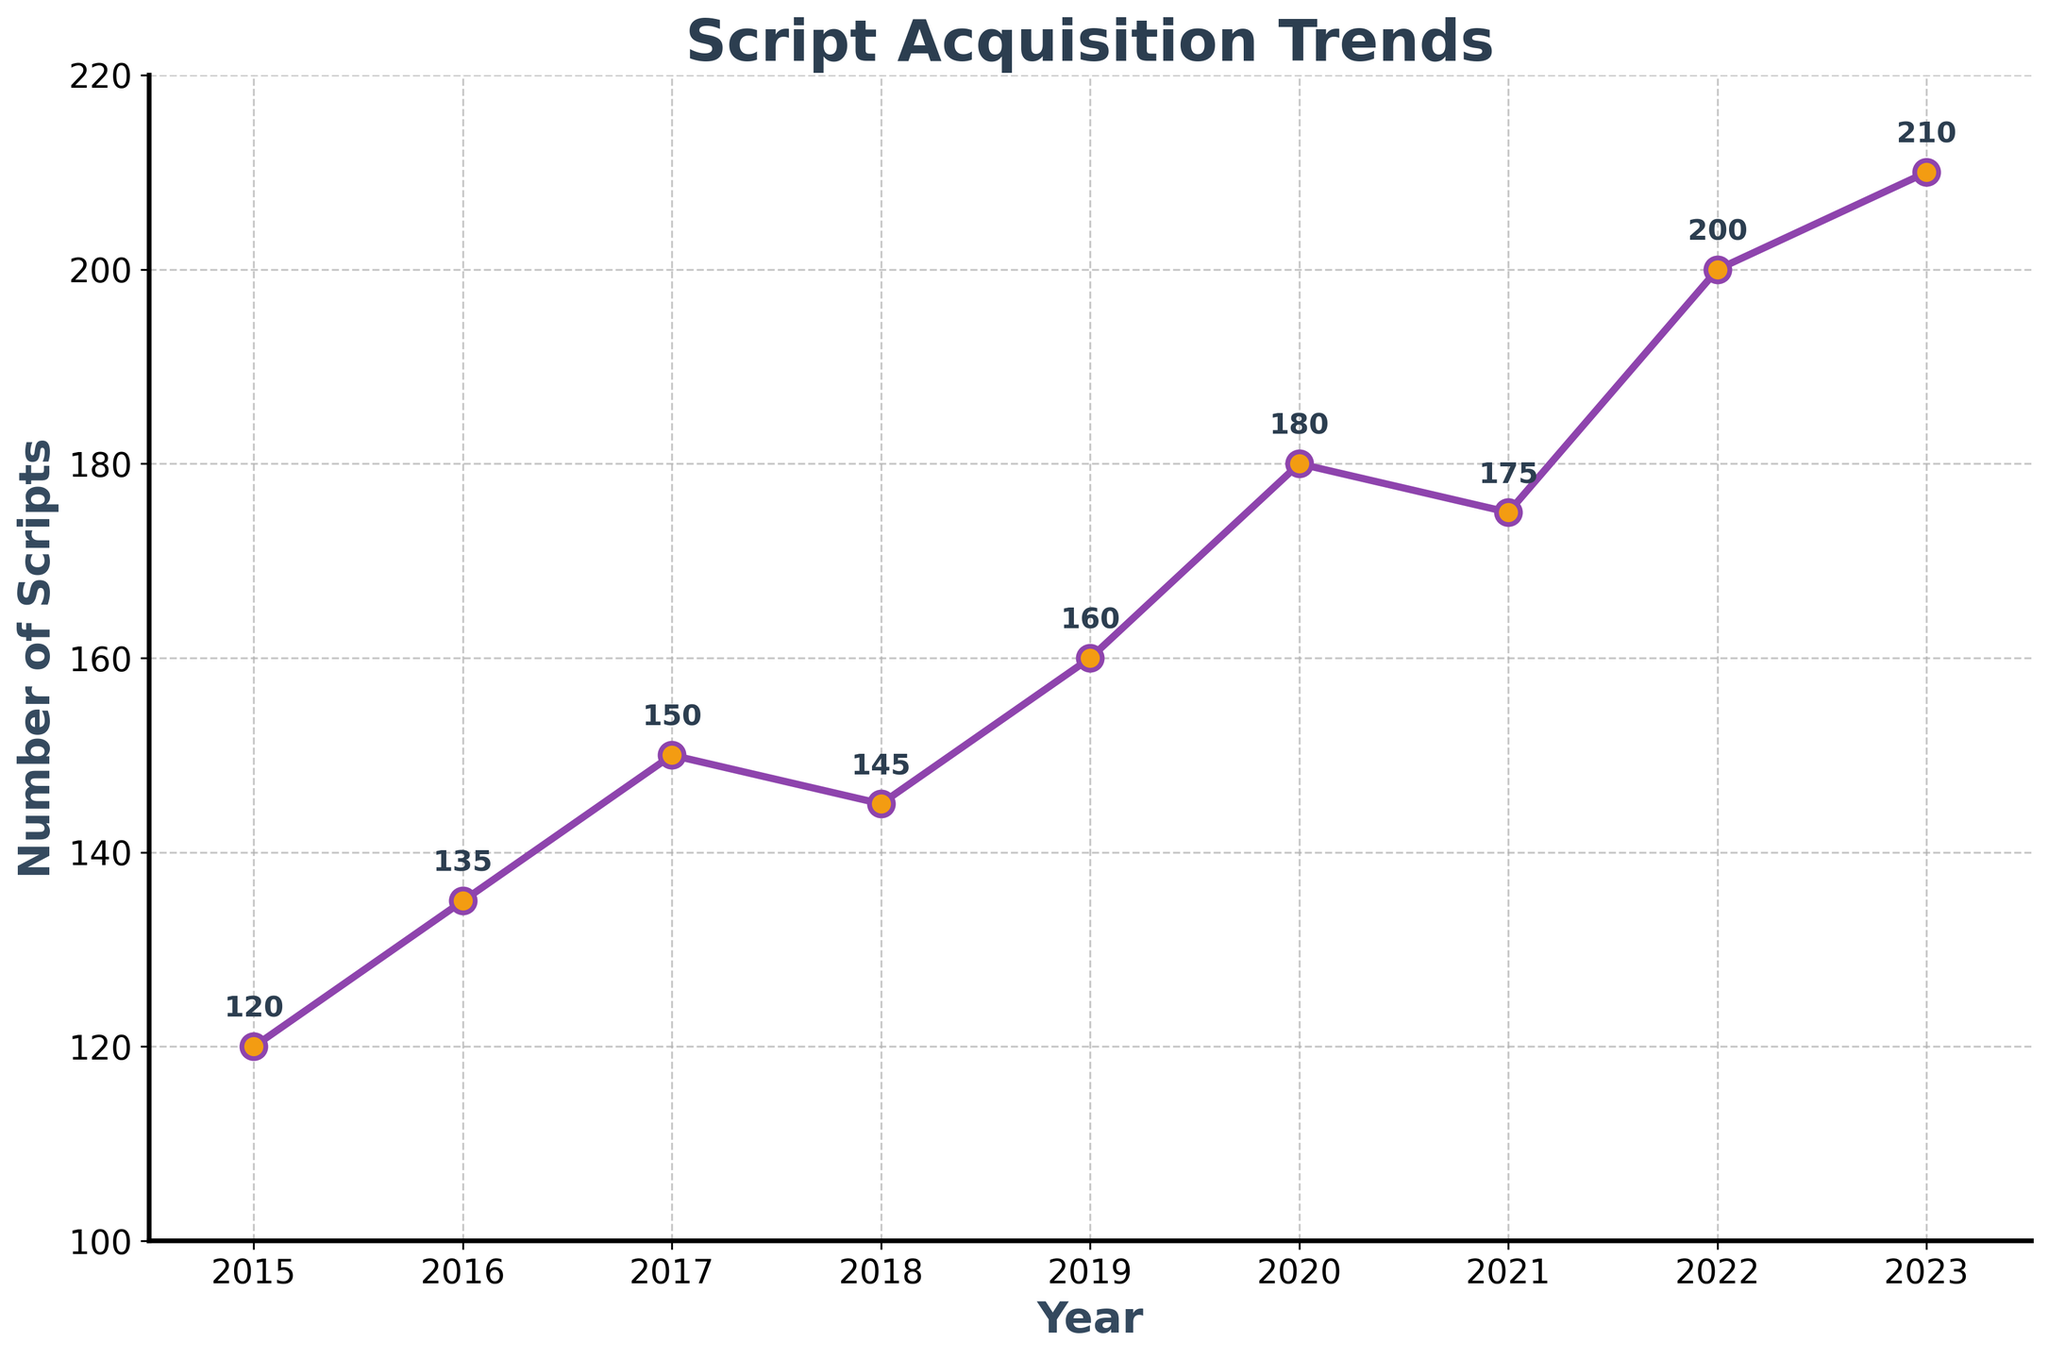What's the title of the plot? The title of the plot is written at the top of the figure, usually in a larger and bolder font.
Answer: Script Acquisition Trends How many years of data are shown in the plot? Count the number of data points plotted on the x-axis, each marked with a specific year.
Answer: 9 years What is the highest number of scripts submitted in a year? Look for the highest data point on the y-axis and see the associated value.
Answer: 210 How did the number of script submissions change from 2018 to 2019? Locate the data points for the years 2018 and 2019. Subtract the 2018 value from the 2019 value to determine the change. 160 - 145 = 15
Answer: Increased by 15 Which year had the lowest number of script submissions? Identify the data point with the smallest value on the y-axis and note its corresponding year on the x-axis.
Answer: 2015 What is the average number of scripts submitted over the years shown? Add up all the script submission values and divide by the number of years (9). (120 + 135 + 150 + 145 + 160 + 180 + 175 + 200 + 210) / 9 = 164.4
Answer: 164.4 Between which consecutive years was the largest increase in script submissions observed? Calculate the absolute differences between consecutive years. Identify the pair of years with the largest difference. 2019-2018: 15, 2020-2019: 20
Answer: Between 2019 and 2020 What is the median number of script submissions? Sort the number of submissions in ascending order and find the middle value. Sorted values: 120, 135, 145, 150, 160, 175, 180, 200, 210. The middle value is the fifth one, which is 160
Answer: 160 How many scripts were submitted in 2022? Look for the data point corresponding to the year 2022 and note its value.
Answer: 200 Did the number of script submissions increase or decrease in 2021 compared to 2020? Compare the values for the years 2020 and 2021. In 2020, there were 180 scripts and in 2021, there were 175 scripts.
Answer: Decrease 